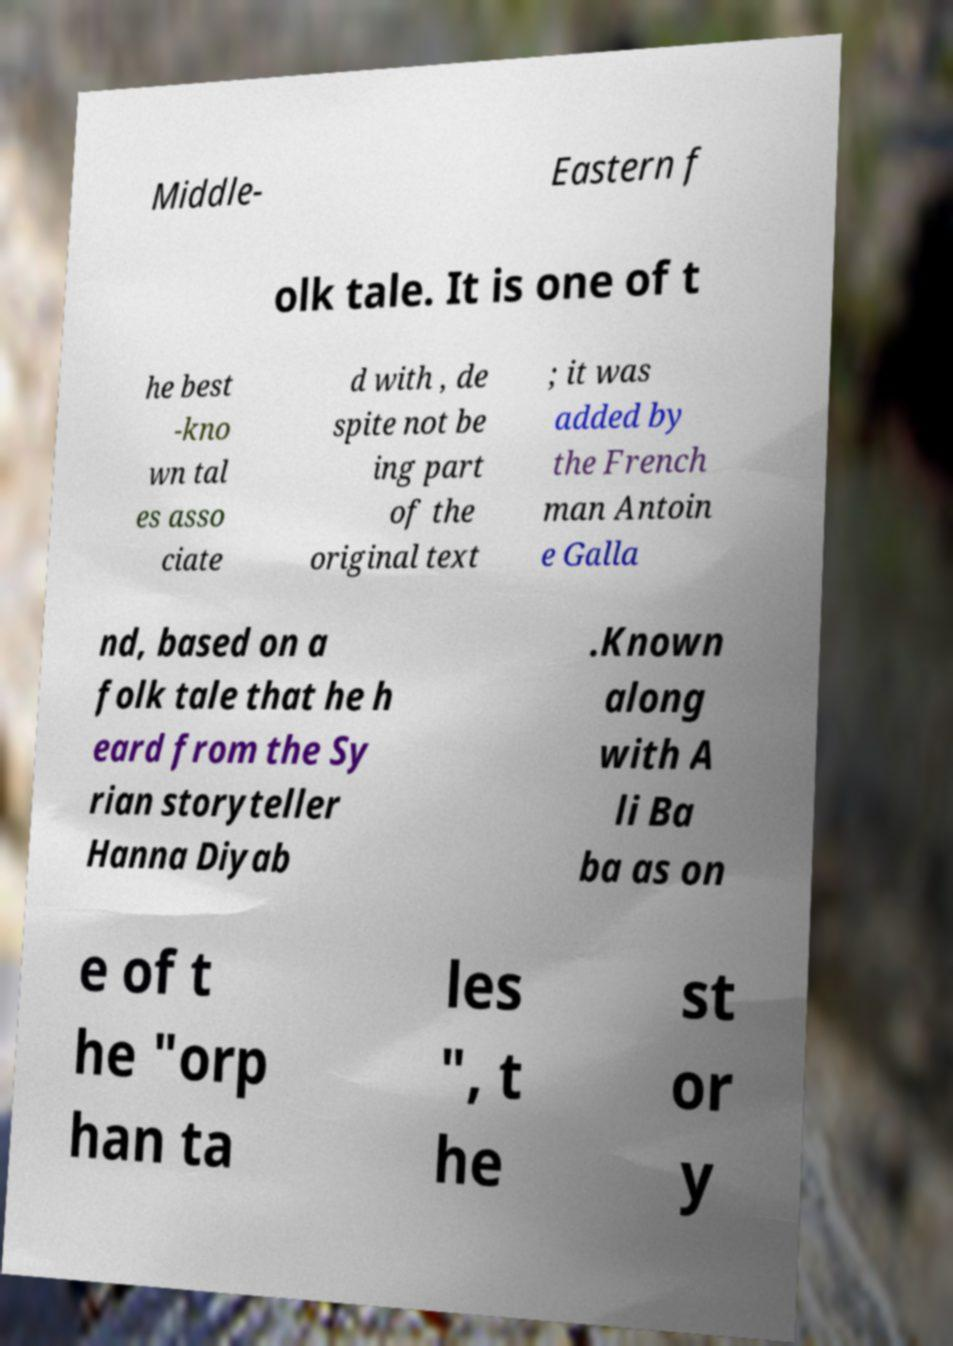Please identify and transcribe the text found in this image. Middle- Eastern f olk tale. It is one of t he best -kno wn tal es asso ciate d with , de spite not be ing part of the original text ; it was added by the French man Antoin e Galla nd, based on a folk tale that he h eard from the Sy rian storyteller Hanna Diyab .Known along with A li Ba ba as on e of t he "orp han ta les ", t he st or y 